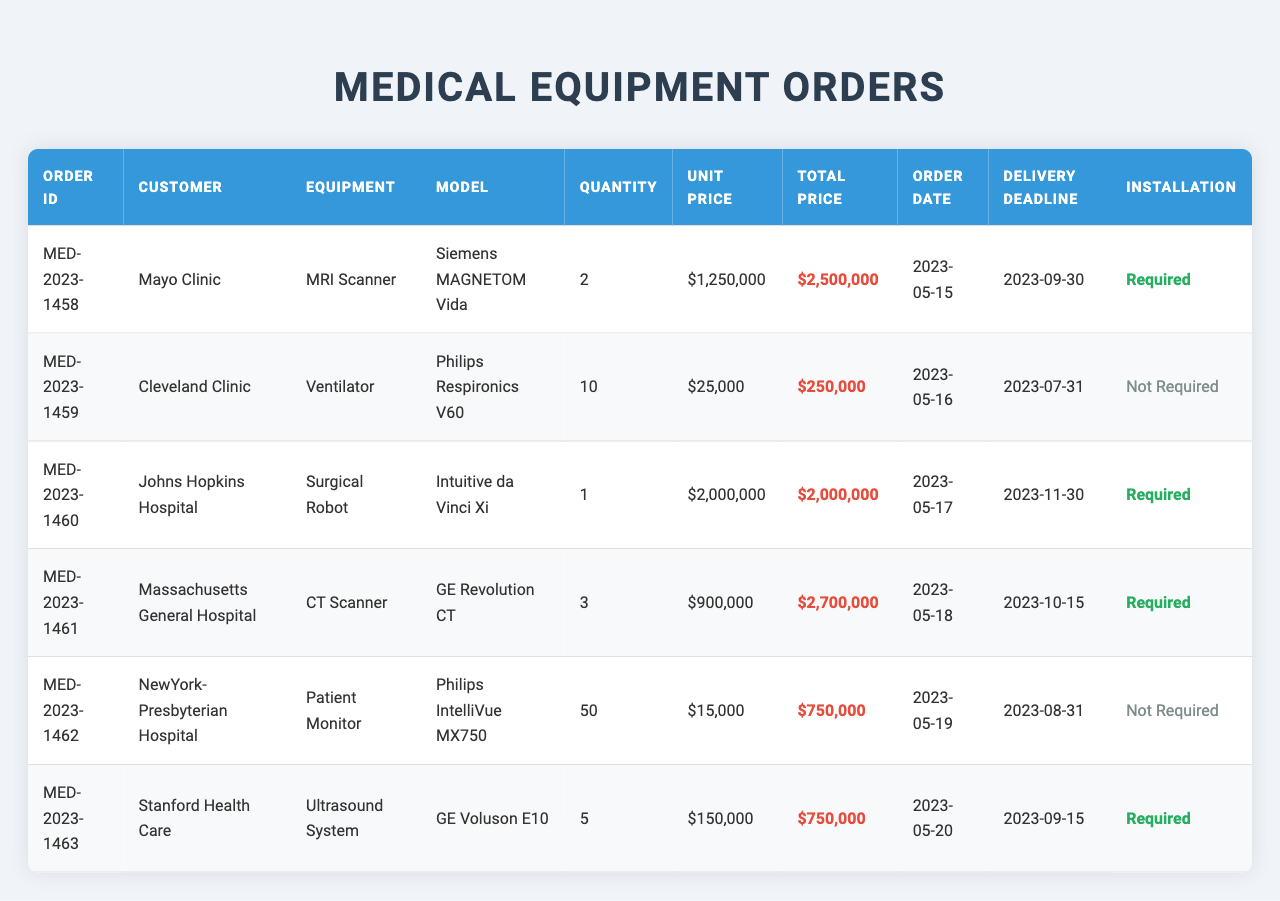What is the total price of the order from Mayo Clinic? The total price for the order with the order ID MED-2023-1458 is listed as $2,500,000 in the table.
Answer: $2,500,000 How many units of the Ventilator were ordered by Cleveland Clinic? According to the table, Cleveland Clinic (order ID MED-2023-1459) ordered 10 units of the Ventilator.
Answer: 10 Which equipment type has the highest unit price? By checking the unit prices listed in the table, the Surgical Robot from Johns Hopkins Hospital has the highest unit price at $2,000,000.
Answer: Surgical Robot What is the total value of all orders combined? The total price values from each order are $2,500,000 (Mayo Clinic) + $250,000 (Cleveland Clinic) + $2,000,000 (Johns Hopkins Hospital) + $2,700,000 (Massachusetts General Hospital) + $750,000 (NewYork-Presbyterian Hospital) + $750,000 (Stanford Health Care), totaling $8,950,000.
Answer: $8,950,000 How many orders required installation? From the table, the orders requiring installation are from Mayo Clinic, Johns Hopkins Hospital, Massachusetts General Hospital, and Stanford Health Care, which totals 4 orders.
Answer: 4 What is the average unit price of all equipment types ordered? To find the average, add the unit prices: $1,250,000 (MRI Scanner) + $25,000 (Ventilator) + $2,000,000 (Surgical Robot) + $900,000 (CT Scanner) + $15,000 (Patient Monitor) + $150,000 (Ultrasound System) = $4,340,000. Then divide by the number of orders (6), resulting in an average unit price of $723,333.33.
Answer: $723,333.33 Was the delivery deadline for the Patient Monitor order before the Surgical Robot order? The Patient Monitor (NewYork-Presbyterian Hospital) has a delivery deadline of August 31, 2023, while the Surgical Robot (Johns Hopkins Hospital) has a deadline of November 30, 2023. Therefore, the Patient Monitor's deadline is earlier.
Answer: Yes How many total units of equipment were ordered across all orders? The total quantity of equipment units ordered can be summed: 2 (MRI Scanner) + 10 (Ventilator) + 1 (Surgical Robot) + 3 (CT Scanner) + 50 (Patient Monitor) + 5 (Ultrasound System) = 71 units total.
Answer: 71 Which customer has the earliest order date? By comparing the order dates, Mayo Clinic has the earliest order date of May 15, 2023.
Answer: Mayo Clinic How much is the second highest total price among all orders? The total prices in descending order are: $2,500,000 (Mayo Clinic), $2,700,000 (Massachusetts General Hospital), $2,000,000 (Johns Hopkins Hospital), $750,000 (NewYork-Presbyterian Hospital), $750,000 (Stanford Health Care), and $250,000 (Cleveland Clinic). The second highest total price is $2,700,000.
Answer: $2,700,000 Is there any order from Cleveland Clinic that required installation? Based on the table, the order from Cleveland Clinic does not require installation, as indicated in the 'Installation' column.
Answer: No 